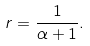<formula> <loc_0><loc_0><loc_500><loc_500>r = \frac { 1 } { \alpha + 1 } .</formula> 